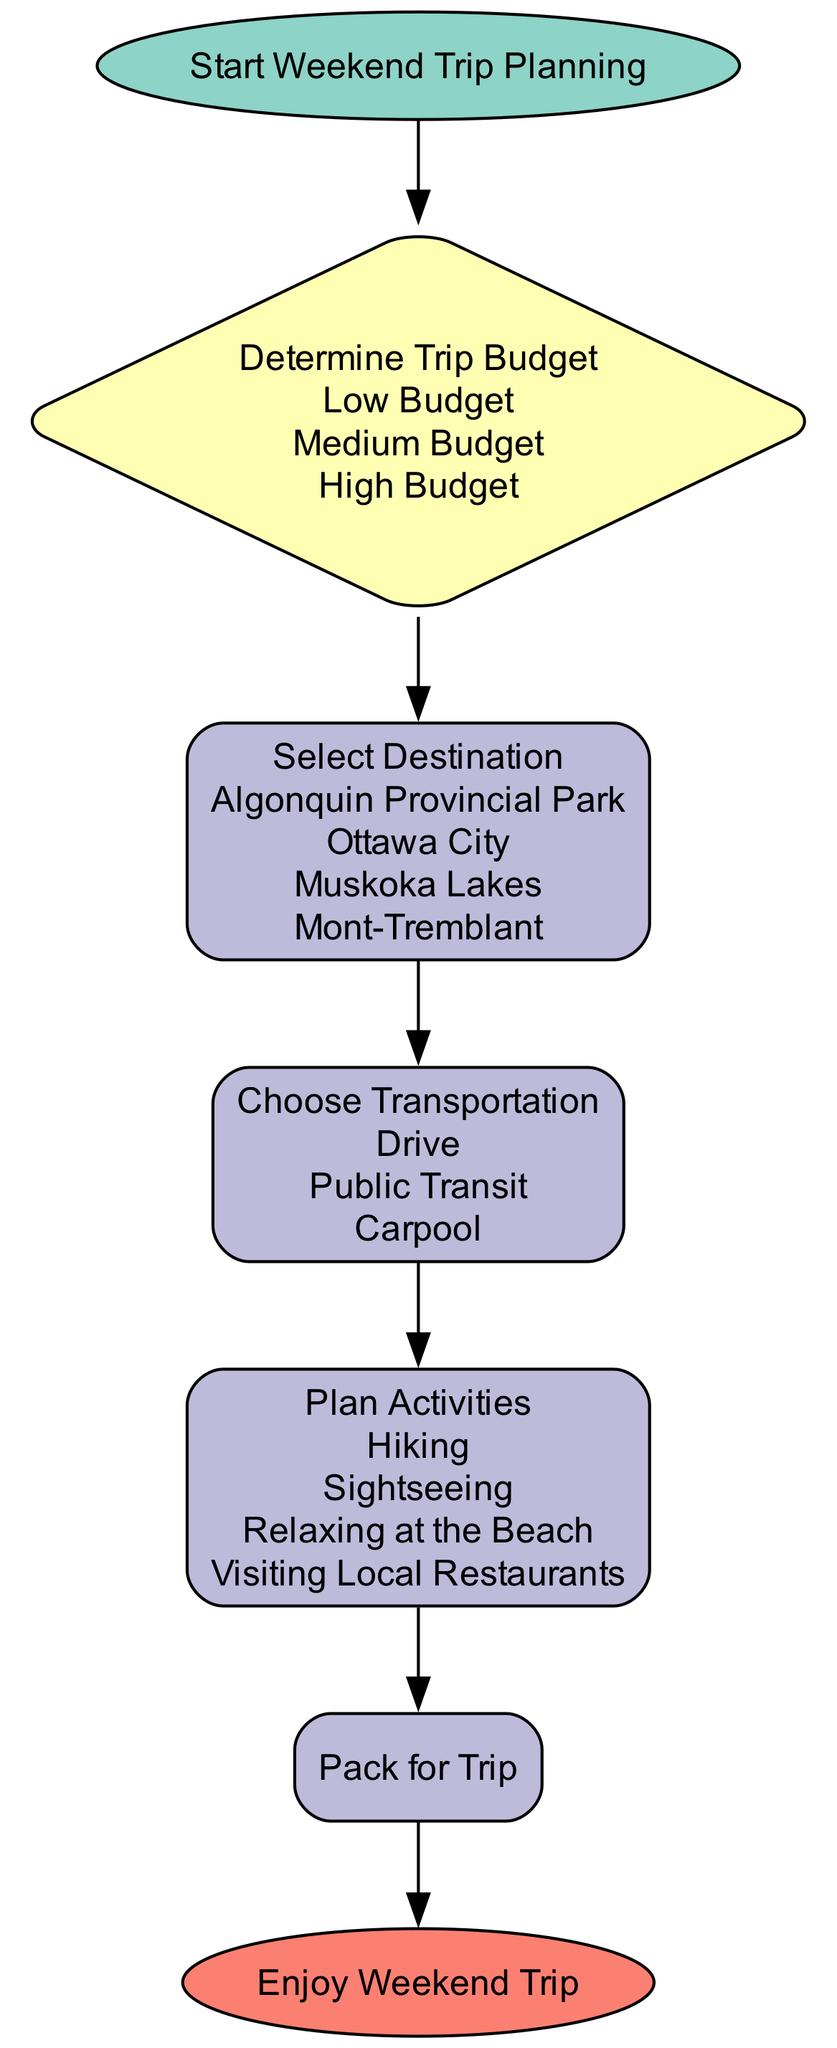What is the first step in the flow chart? The first step indicates the starting point of the process, which is "Start Weekend Trip Planning."
Answer: Start Weekend Trip Planning How many options are available for the destination selection? The diagram lists four destinations: Algonquin Provincial Park, Ottawa City, Muskoka Lakes, and Mont-Tremblant. Counting these options gives a total of four.
Answer: Four What are the transportation options listed in the diagram? The node titled "Choose Transportation" provides three options: Drive, Public Transit, and Carpool. The response combines all these options.
Answer: Drive, Public Transit, Carpool After determining the trip budget, which step follows next in the flow? The diagram shows that after "Determine Trip Budget," the next process is "Select Destination." This establishes a clear flow of activities.
Answer: Select Destination If the budget is high, what is the sequence of steps that follows? Starting from the "Determine Trip Budget" node, if the budget is high, it leads to "Select Destination," followed by "Choose Transportation," "Plan Activities," "Pack for Trip," and finally "Enjoy Weekend Trip." This sequence outlines the complete flow after this decision.
Answer: Select Destination, Choose Transportation, Plan Activities, Pack for Trip, Enjoy Weekend Trip What shape is used for decision-making nodes in the diagram? The decision-making nodes, such as "Determine Trip Budget," are represented using a diamond shape, indicating the nature of decision-making in this area.
Answer: Diamond How many total nodes are present in the diagram? Counting the nodes, there are a total of six nodes represented: Start, Determine Trip Budget, Select Destination, Choose Transportation, Plan Activities, Pack for Trip, and End. The total gives six distinct nodes in the flow chart.
Answer: Six What activity is suggested last in the flow chart? The flow chart concludes with the node titled "Enjoy Weekend Trip," indicating that this is the final step in the weekend trip planning process.
Answer: Enjoy Weekend Trip 